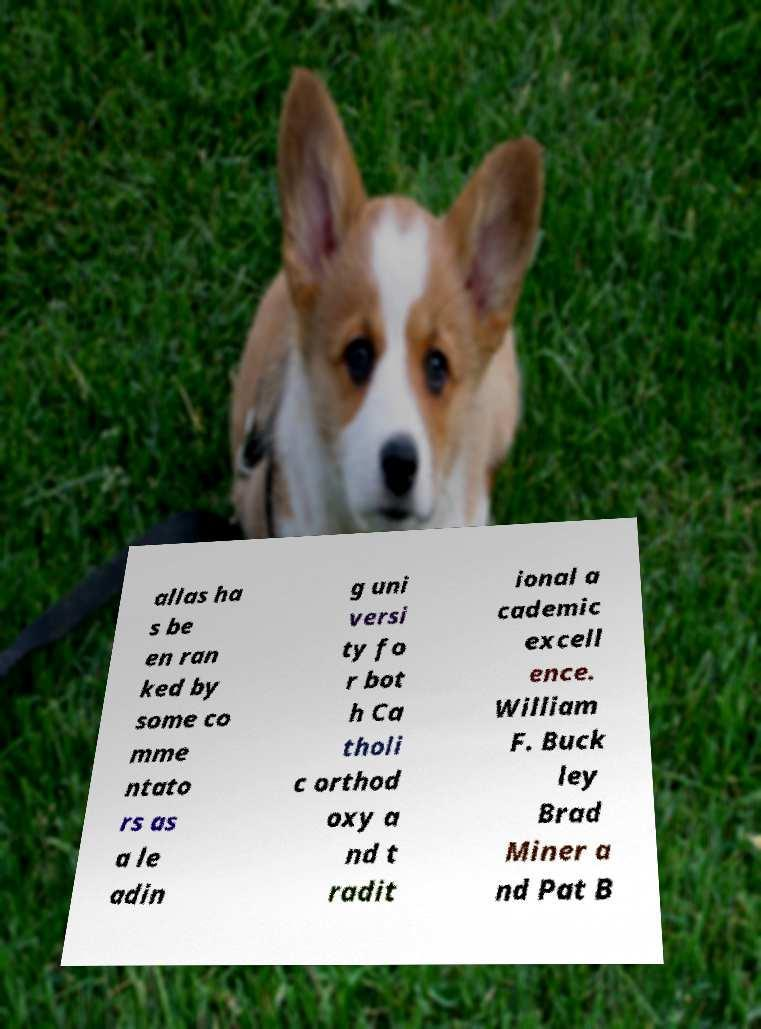Can you accurately transcribe the text from the provided image for me? allas ha s be en ran ked by some co mme ntato rs as a le adin g uni versi ty fo r bot h Ca tholi c orthod oxy a nd t radit ional a cademic excell ence. William F. Buck ley Brad Miner a nd Pat B 